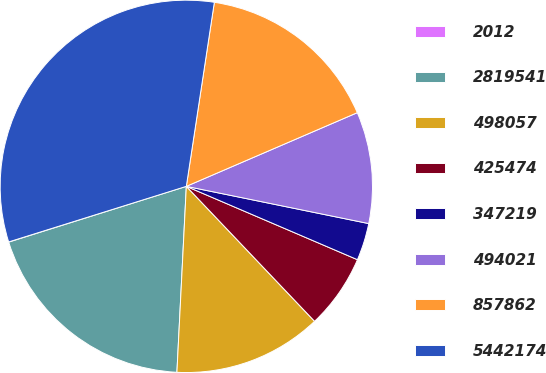<chart> <loc_0><loc_0><loc_500><loc_500><pie_chart><fcel>2012<fcel>2819541<fcel>498057<fcel>425474<fcel>347219<fcel>494021<fcel>857862<fcel>5442174<nl><fcel>0.02%<fcel>19.35%<fcel>12.9%<fcel>6.46%<fcel>3.24%<fcel>9.68%<fcel>16.12%<fcel>32.23%<nl></chart> 